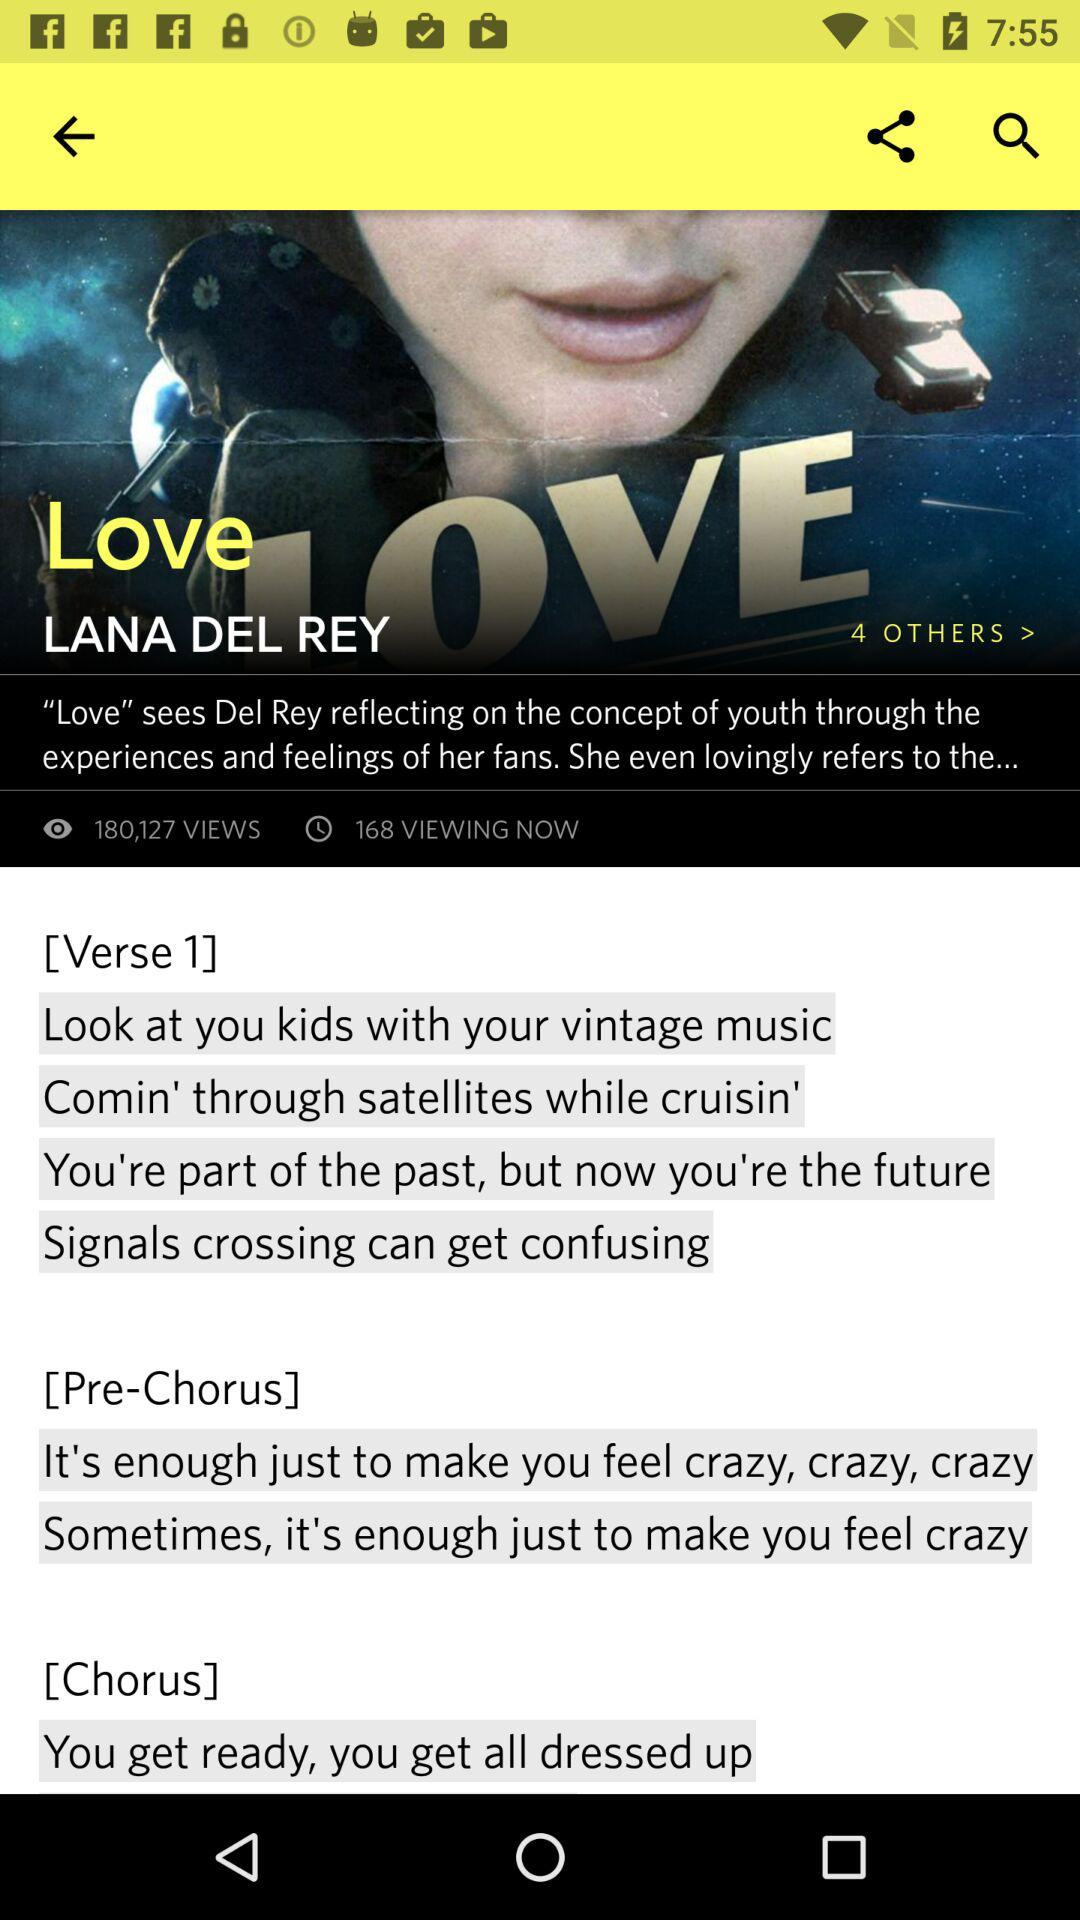What is the name of the song? The name of the song is "Love". 